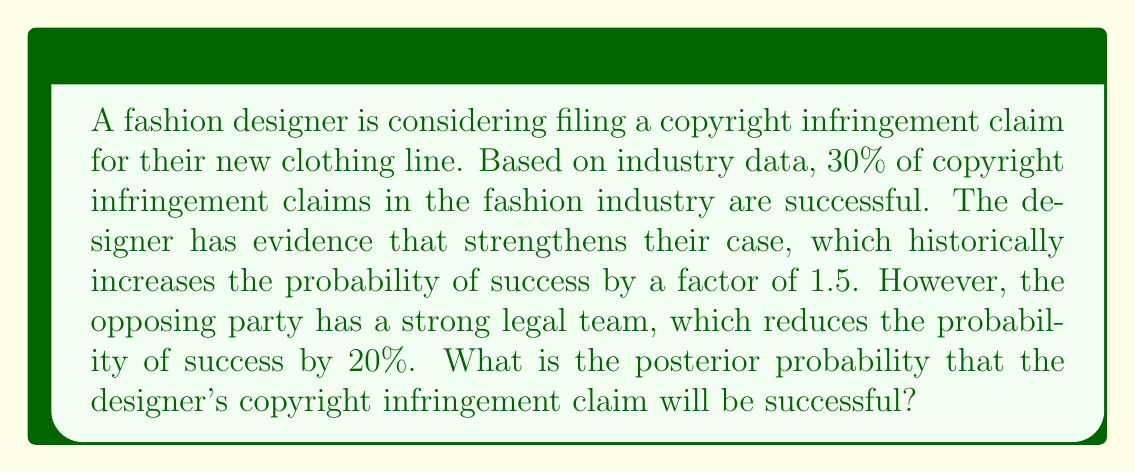Solve this math problem. Let's approach this problem using Bayesian reasoning:

1. Define our events:
   A: The copyright infringement claim is successful
   B: The designer has strong evidence
   C: The opposing party has a strong legal team

2. Given information:
   P(A) = 0.30 (prior probability of success)
   P(A|B) = 1.5 * P(A) (probability of success given strong evidence)
   P(A|C) = 0.8 * P(A) (probability of success given opposing strong legal team)

3. Calculate P(A|B):
   P(A|B) = 1.5 * P(A) = 1.5 * 0.30 = 0.45

4. Now, we need to calculate P(A|B,C), which is the probability of success given both the strong evidence and the opposing strong legal team.

5. We can use the following formula:
   $$P(A|B,C) = \frac{P(C|A,B) * P(A|B)}{P(C|B)}$$

6. We don't have direct information about P(C|A,B) or P(C|B), but we can estimate:
   P(A|C) = 0.8 * P(A)
   So, P(C|A) ≈ 0.8 (assuming the effect is symmetrical)

7. Applying this to our formula:
   $$P(A|B,C) \approx 0.8 * P(A|B) = 0.8 * 0.45 = 0.36$$

8. Therefore, the posterior probability of a successful copyright infringement claim, given the designer's strong evidence and the opposing party's strong legal team, is approximately 0.36 or 36%.
Answer: The posterior probability that the designer's copyright infringement claim will be successful is approximately 0.36 or 36%. 